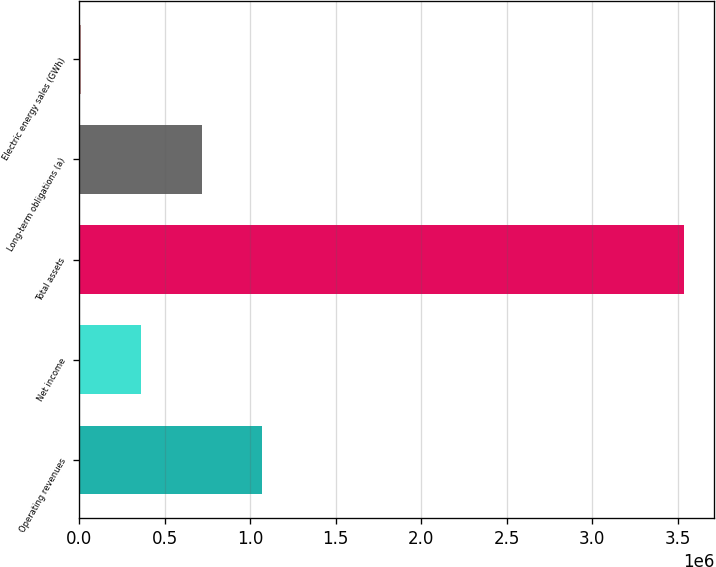<chart> <loc_0><loc_0><loc_500><loc_500><bar_chart><fcel>Operating revenues<fcel>Net income<fcel>Total assets<fcel>Long-term obligations (a)<fcel>Electric energy sales (GWh)<nl><fcel>1.06808e+06<fcel>362556<fcel>3.53741e+06<fcel>715318<fcel>9794<nl></chart> 